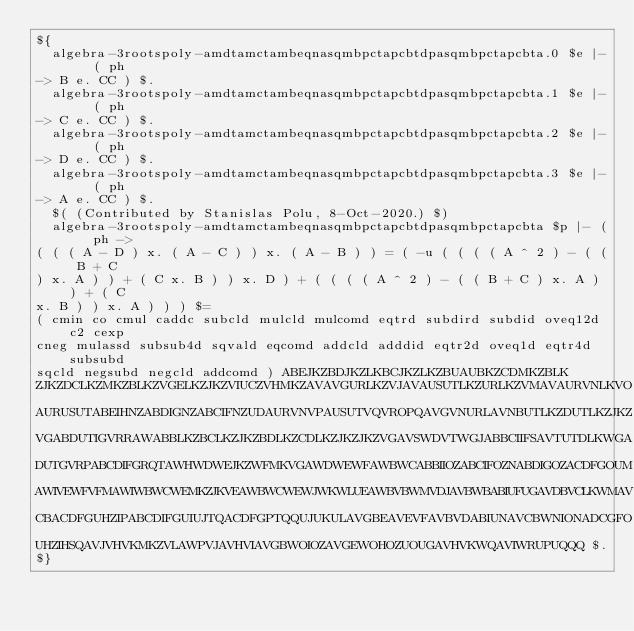<code> <loc_0><loc_0><loc_500><loc_500><_ObjectiveC_>${
  algebra-3rootspoly-amdtamctambeqnasqmbpctapcbtdpasqmbpctapcbta.0 $e |- ( ph 
-> B e. CC ) $.
  algebra-3rootspoly-amdtamctambeqnasqmbpctapcbtdpasqmbpctapcbta.1 $e |- ( ph 
-> C e. CC ) $.
  algebra-3rootspoly-amdtamctambeqnasqmbpctapcbtdpasqmbpctapcbta.2 $e |- ( ph 
-> D e. CC ) $.
  algebra-3rootspoly-amdtamctambeqnasqmbpctapcbtdpasqmbpctapcbta.3 $e |- ( ph 
-> A e. CC ) $.
  $( (Contributed by Stanislas Polu, 8-Oct-2020.) $)
  algebra-3rootspoly-amdtamctambeqnasqmbpctapcbtdpasqmbpctapcbta $p |- ( ph -> 
( ( ( A - D ) x. ( A - C ) ) x. ( A - B ) ) = ( -u ( ( ( ( A ^ 2 ) - ( ( B + C 
) x. A ) ) + ( C x. B ) ) x. D ) + ( ( ( ( A ^ 2 ) - ( ( B + C ) x. A ) ) + ( C 
x. B ) ) x. A ) ) ) $=
( cmin co cmul caddc subcld mulcld mulcomd eqtrd subdird subdid oveq12d c2 cexp 
cneg mulassd subsub4d sqvald eqcomd addcld adddid eqtr2d oveq1d eqtr4d subsubd 
sqcld negsubd negcld addcomd ) ABEJKZBDJKZLKBCJKZLKZBUAUBKZCDMKZBLK 
ZJKZDCLKZMKZBLKZVGELKZJKZVIUCZVHMKZAVAVGURLKZVJAVAUSUTLKZURLKZVMAVAURVNLKVO 
AURUSUTABEIHNZABDIGNZABCIFNZUDAURVNVPAUSUTVQVROPQAVGVNURLAVNBUTLKZDUTLKZJKZ 
VGABDUTIGVRRAWABBLKZBCLKZJKZBDLKZCDLKZJKZJKZVGAVSWDVTWGJABBCIIFSAVTUTDLKWGA 
DUTGVRPABCDIFGRQTAWHWDWEJKZWFMKVGAWDWEWFAWBWCABBIIOZABCIFOZNABDIGOZACDFGOUM 
AWIVEWFVFMAWIWBWCWEMKZJKVEAWBWCWEWJWKWLUEAWBVBWMVDJAVBWBABIUFUGAVDBVCLKWMAV 
CBACDFGUHZIPABCDIFGUIUJTQACDFGPTQQUJUKULAVGBEAVEVFAVBVDABIUNAVCBWNIONADCGFO 
UHZIHSQAVJVHVKMKZVLAWPVJAVHVIAVGBWOIOZAVGEWOHOZUOUGAVHVKWQAVIWRUPUQQQ $. 
$}
</code> 